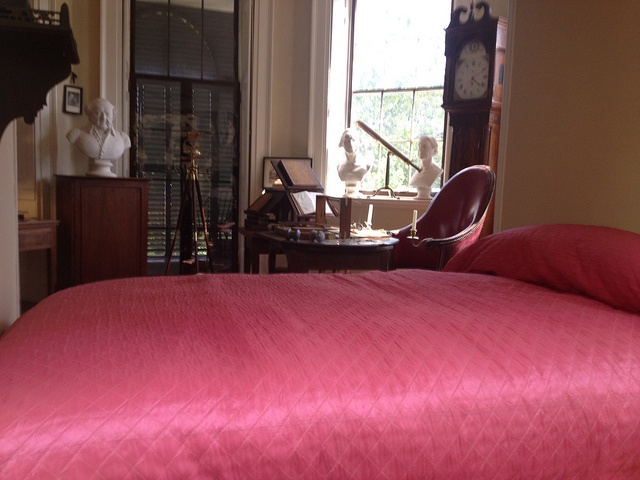Describe the objects in this image and their specific colors. I can see bed in black, salmon, and brown tones, chair in black, maroon, gray, and brown tones, and clock in black and gray tones in this image. 